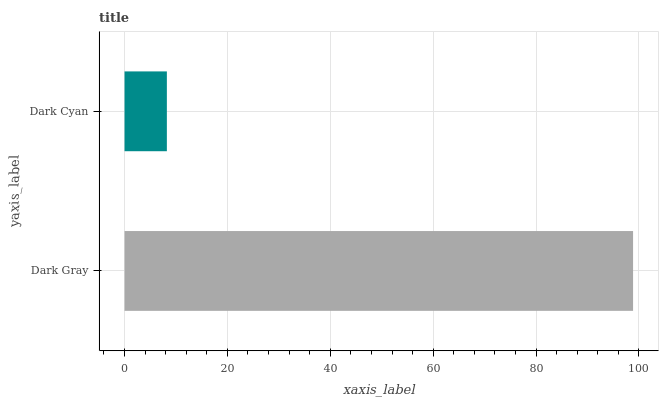Is Dark Cyan the minimum?
Answer yes or no. Yes. Is Dark Gray the maximum?
Answer yes or no. Yes. Is Dark Cyan the maximum?
Answer yes or no. No. Is Dark Gray greater than Dark Cyan?
Answer yes or no. Yes. Is Dark Cyan less than Dark Gray?
Answer yes or no. Yes. Is Dark Cyan greater than Dark Gray?
Answer yes or no. No. Is Dark Gray less than Dark Cyan?
Answer yes or no. No. Is Dark Gray the high median?
Answer yes or no. Yes. Is Dark Cyan the low median?
Answer yes or no. Yes. Is Dark Cyan the high median?
Answer yes or no. No. Is Dark Gray the low median?
Answer yes or no. No. 